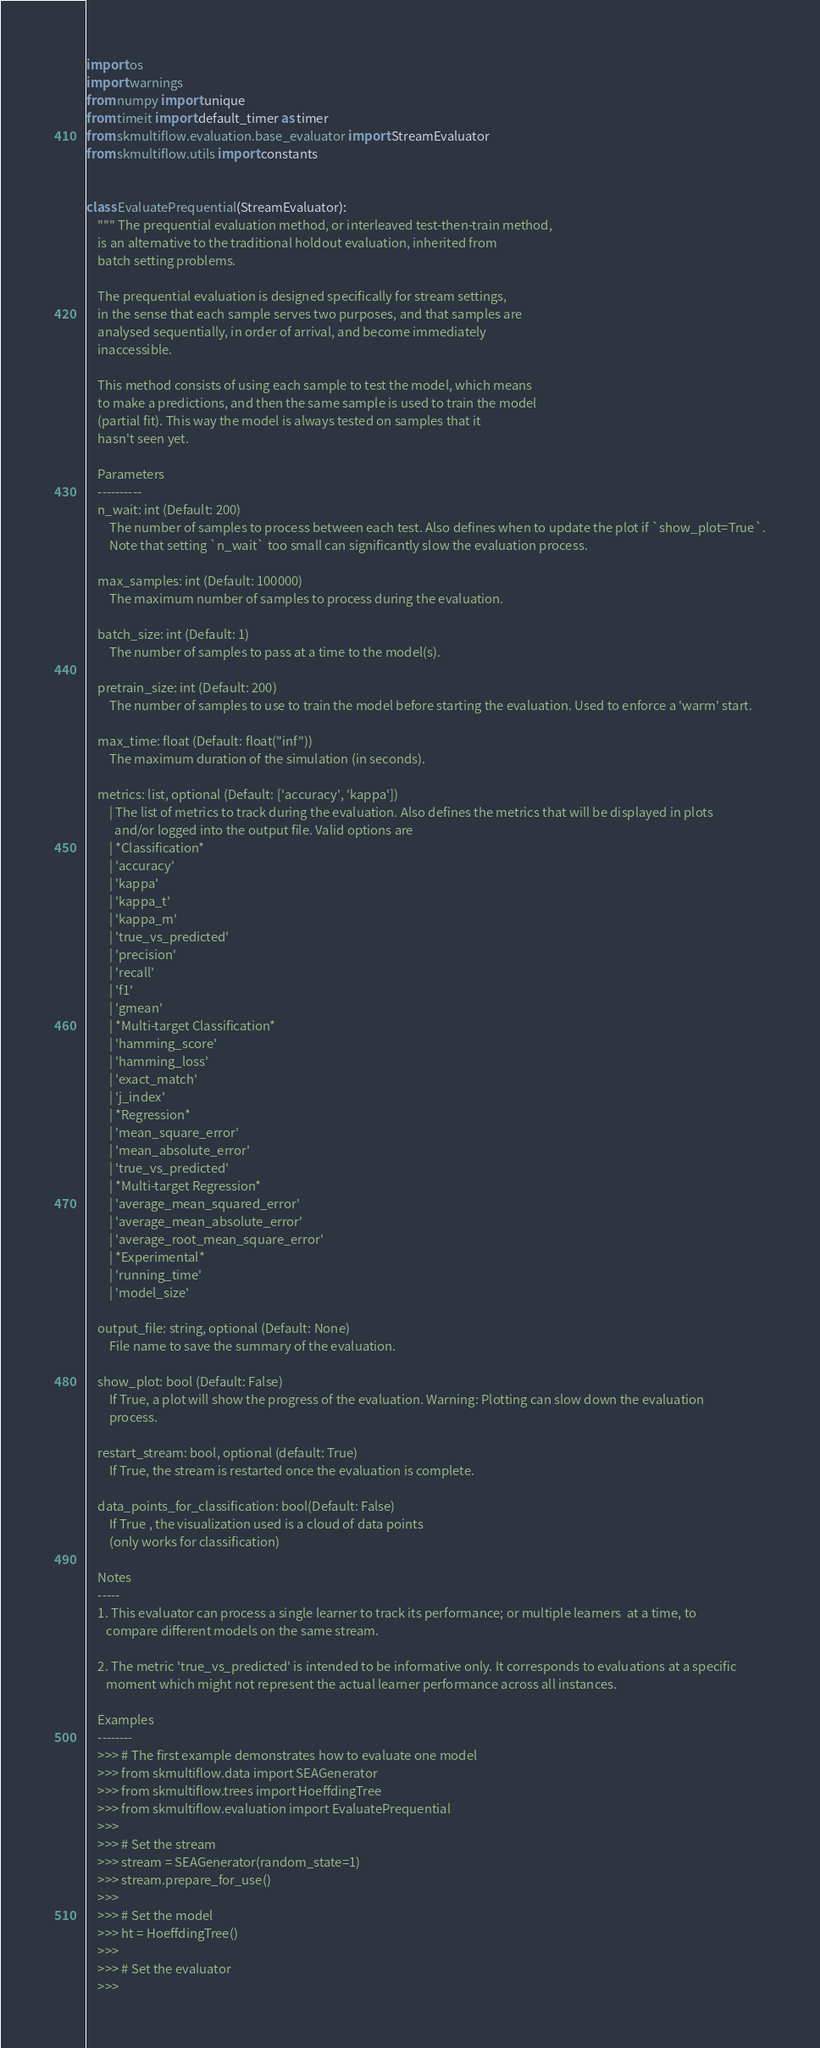<code> <loc_0><loc_0><loc_500><loc_500><_Python_>import os
import warnings
from numpy import unique
from timeit import default_timer as timer
from skmultiflow.evaluation.base_evaluator import StreamEvaluator
from skmultiflow.utils import constants


class EvaluatePrequential(StreamEvaluator):
    """ The prequential evaluation method, or interleaved test-then-train method,
    is an alternative to the traditional holdout evaluation, inherited from
    batch setting problems.

    The prequential evaluation is designed specifically for stream settings,
    in the sense that each sample serves two purposes, and that samples are
    analysed sequentially, in order of arrival, and become immediately
    inaccessible.

    This method consists of using each sample to test the model, which means
    to make a predictions, and then the same sample is used to train the model
    (partial fit). This way the model is always tested on samples that it
    hasn't seen yet.

    Parameters
    ----------
    n_wait: int (Default: 200)
        The number of samples to process between each test. Also defines when to update the plot if `show_plot=True`.
        Note that setting `n_wait` too small can significantly slow the evaluation process.

    max_samples: int (Default: 100000)
        The maximum number of samples to process during the evaluation.

    batch_size: int (Default: 1)
        The number of samples to pass at a time to the model(s).

    pretrain_size: int (Default: 200)
        The number of samples to use to train the model before starting the evaluation. Used to enforce a 'warm' start.

    max_time: float (Default: float("inf"))
        The maximum duration of the simulation (in seconds).

    metrics: list, optional (Default: ['accuracy', 'kappa'])
        | The list of metrics to track during the evaluation. Also defines the metrics that will be displayed in plots
          and/or logged into the output file. Valid options are
        | *Classification*
        | 'accuracy'
        | 'kappa'
        | 'kappa_t'
        | 'kappa_m'
        | 'true_vs_predicted'
        | 'precision'
        | 'recall'
        | 'f1'
        | 'gmean'
        | *Multi-target Classification*
        | 'hamming_score'
        | 'hamming_loss'
        | 'exact_match'
        | 'j_index'
        | *Regression*
        | 'mean_square_error'
        | 'mean_absolute_error'
        | 'true_vs_predicted'
        | *Multi-target Regression*
        | 'average_mean_squared_error'
        | 'average_mean_absolute_error'
        | 'average_root_mean_square_error'
        | *Experimental*
        | 'running_time'
        | 'model_size'

    output_file: string, optional (Default: None)
        File name to save the summary of the evaluation.

    show_plot: bool (Default: False)
        If True, a plot will show the progress of the evaluation. Warning: Plotting can slow down the evaluation
        process.

    restart_stream: bool, optional (default: True)
        If True, the stream is restarted once the evaluation is complete.

    data_points_for_classification: bool(Default: False)
        If True , the visualization used is a cloud of data points
        (only works for classification)

    Notes
    -----
    1. This evaluator can process a single learner to track its performance; or multiple learners  at a time, to
       compare different models on the same stream.

    2. The metric 'true_vs_predicted' is intended to be informative only. It corresponds to evaluations at a specific
       moment which might not represent the actual learner performance across all instances.

    Examples
    --------
    >>> # The first example demonstrates how to evaluate one model
    >>> from skmultiflow.data import SEAGenerator
    >>> from skmultiflow.trees import HoeffdingTree
    >>> from skmultiflow.evaluation import EvaluatePrequential
    >>>
    >>> # Set the stream
    >>> stream = SEAGenerator(random_state=1)
    >>> stream.prepare_for_use()
    >>>
    >>> # Set the model
    >>> ht = HoeffdingTree()
    >>>
    >>> # Set the evaluator
    >>></code> 